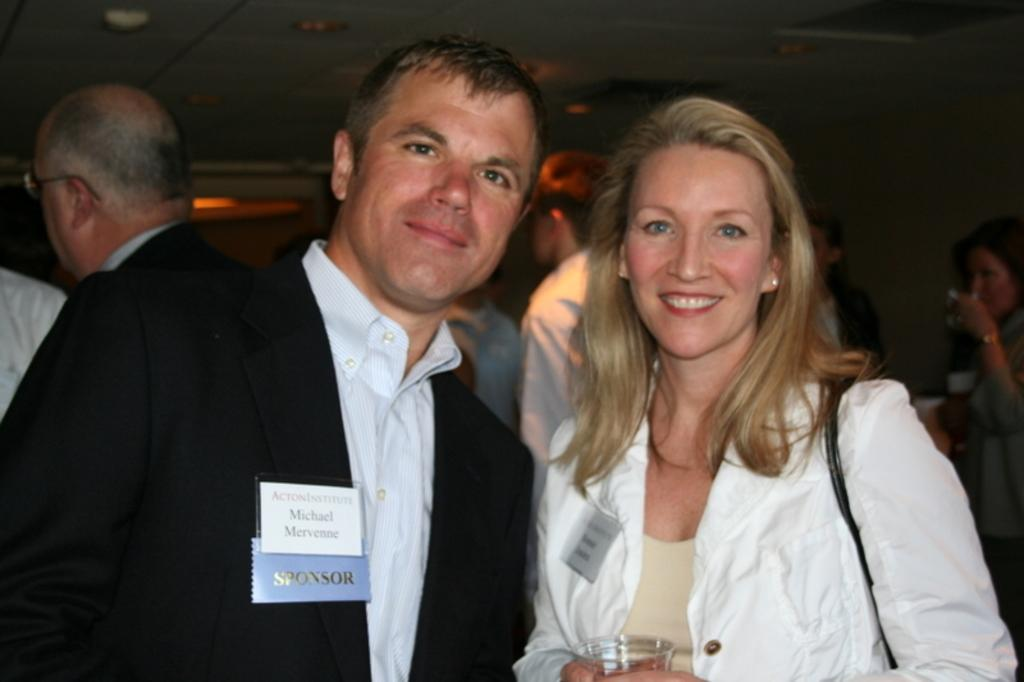How many people are present in the image? There are two people, a man and a woman, present in the image. What are the man and woman doing in the image? Both the man and woman are posing for a camera. What is the woman holding in her hand? The woman is holding a glass in her hand. What can be seen in the background of the image? There are people and the ceiling visible in the background of the image. Reasoning: Let's think step by step by step in order to produce the conversation. We start by identifying the main subjects in the image, which are the man and woman. Then, we describe their actions and the objects they are holding. Next, we expand the conversation to include the background of the image, mentioning the presence of people and the ceiling. Absurd Question/Answer: What is the value of the air in the image? There is no specific value assigned to the air in the image, as air is not a quantifiable object in this context. 